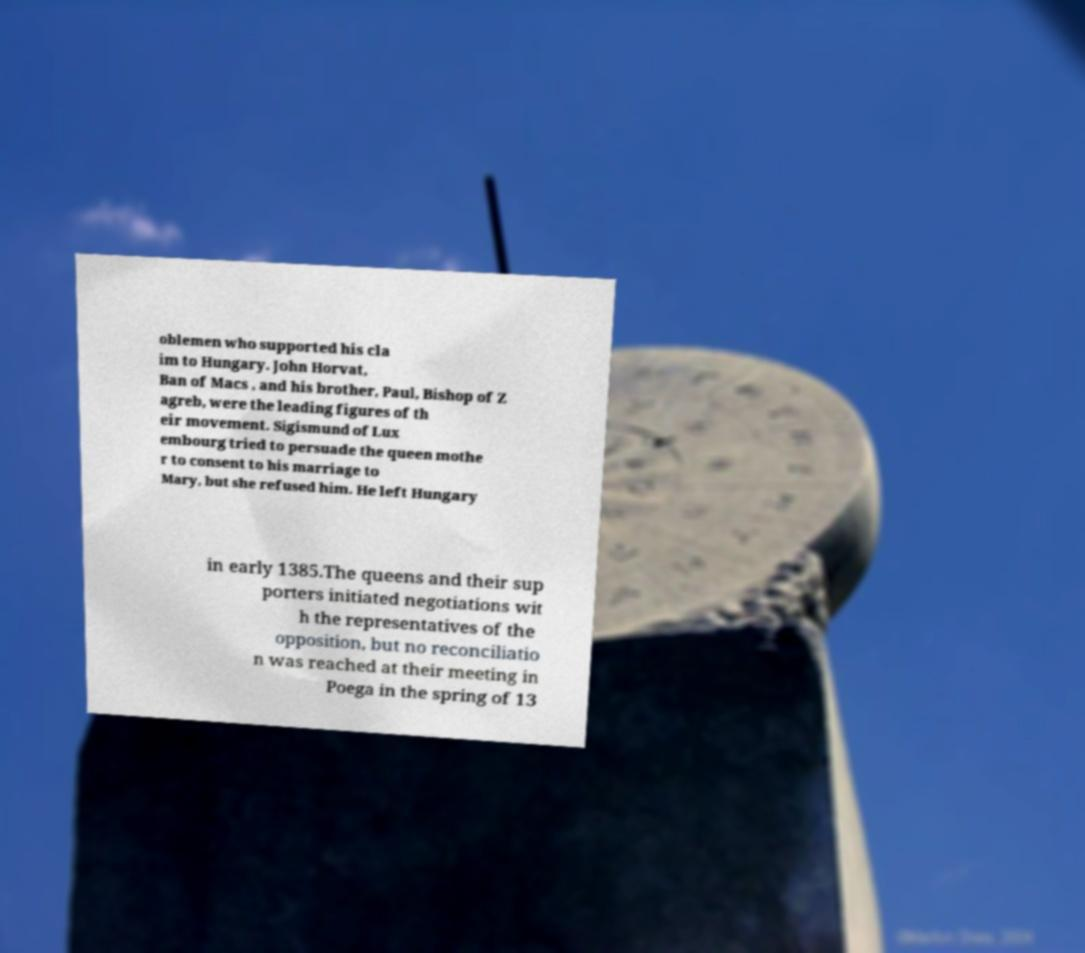What messages or text are displayed in this image? I need them in a readable, typed format. oblemen who supported his cla im to Hungary. John Horvat, Ban of Macs , and his brother, Paul, Bishop of Z agreb, were the leading figures of th eir movement. Sigismund of Lux embourg tried to persuade the queen mothe r to consent to his marriage to Mary, but she refused him. He left Hungary in early 1385.The queens and their sup porters initiated negotiations wit h the representatives of the opposition, but no reconciliatio n was reached at their meeting in Poega in the spring of 13 